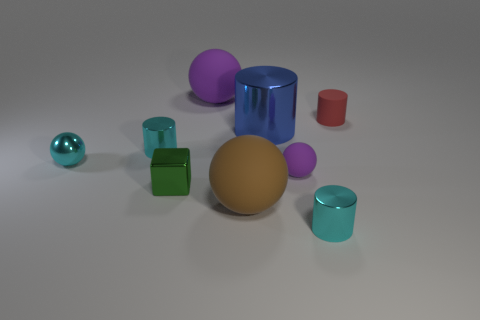There is a thing that is the same color as the small matte sphere; what is its size?
Provide a short and direct response. Large. Is the number of large brown matte spheres greater than the number of big rubber balls?
Your answer should be very brief. No. There is a small cyan metal cylinder behind the tiny metal cube; what number of purple rubber balls are in front of it?
Provide a short and direct response. 1. How many things are big objects on the left side of the brown rubber thing or tiny brown shiny spheres?
Provide a short and direct response. 1. Is there a tiny green matte thing of the same shape as the large metallic object?
Offer a terse response. No. The small green metal object in front of the matte sphere behind the red matte object is what shape?
Ensure brevity in your answer.  Cube. How many balls are big purple things or tiny metallic objects?
Your response must be concise. 2. What material is the object that is the same color as the small rubber sphere?
Provide a short and direct response. Rubber. There is a tiny cyan thing that is to the right of the green block; is it the same shape as the small matte object behind the large blue cylinder?
Keep it short and to the point. Yes. There is a cylinder that is right of the big purple rubber ball and in front of the big cylinder; what color is it?
Ensure brevity in your answer.  Cyan. 